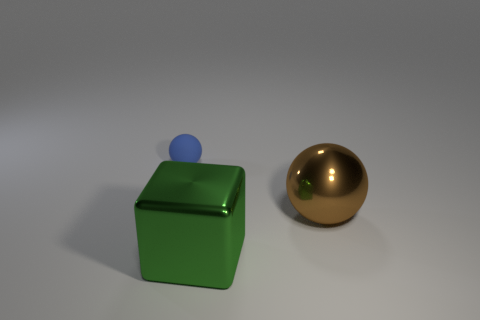Does the tiny matte ball have the same color as the large cube?
Ensure brevity in your answer.  No. Are there fewer large brown metallic balls that are left of the green thing than tiny matte spheres on the left side of the blue object?
Provide a short and direct response. No. Is the tiny object made of the same material as the big green thing?
Ensure brevity in your answer.  No. What size is the object that is both to the left of the brown metal sphere and behind the green block?
Your response must be concise. Small. The thing that is the same size as the shiny block is what shape?
Ensure brevity in your answer.  Sphere. There is a sphere in front of the object to the left of the large green block that is on the left side of the brown metal thing; what is its material?
Provide a succinct answer. Metal. There is a metallic object behind the big metal block; does it have the same shape as the metallic thing in front of the brown object?
Give a very brief answer. No. What number of other things are made of the same material as the tiny blue thing?
Ensure brevity in your answer.  0. Is the material of the big object that is in front of the big brown shiny object the same as the ball that is in front of the blue matte object?
Ensure brevity in your answer.  Yes. What is the shape of the brown thing that is made of the same material as the green object?
Offer a terse response. Sphere. 